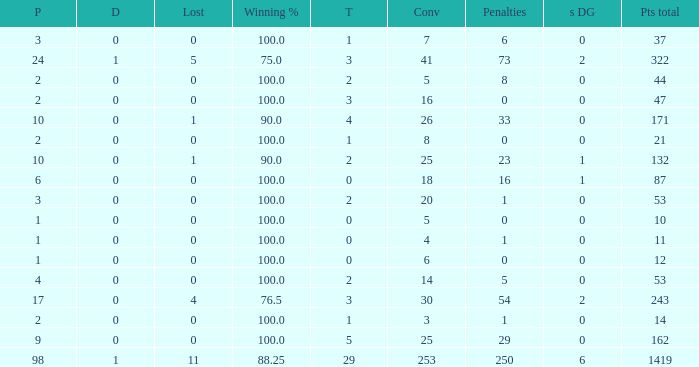What is the least number of penalties he got when his point total was over 1419 in more than 98 games? None. 